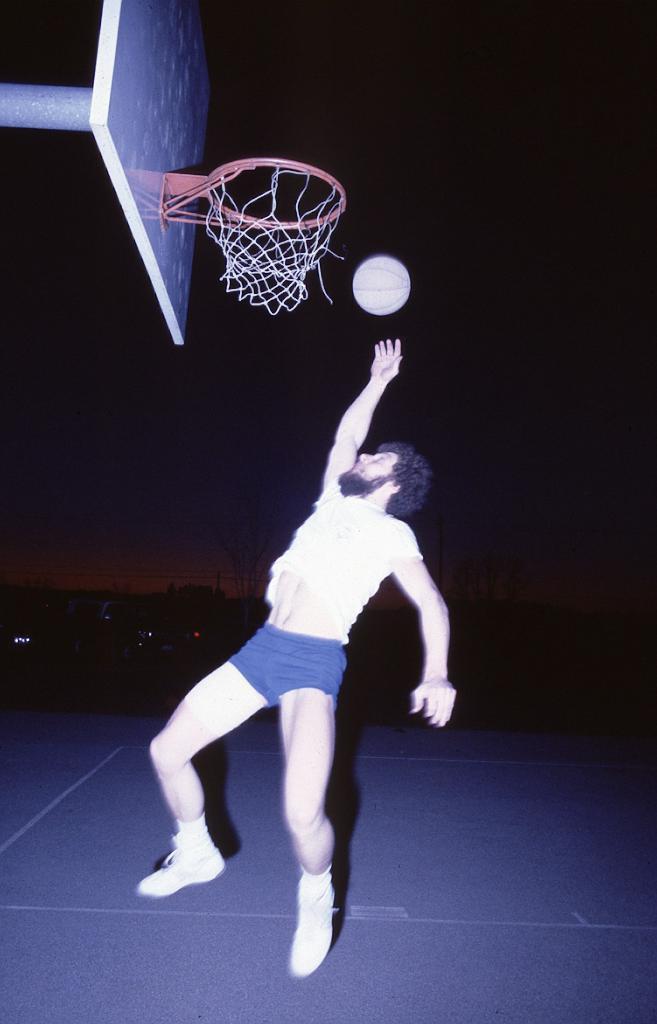In one or two sentences, can you explain what this image depicts? In this image we can see a person playing basketball and in the background, the image is dark. 